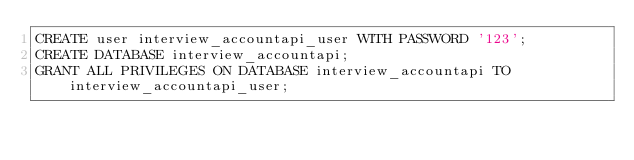Convert code to text. <code><loc_0><loc_0><loc_500><loc_500><_SQL_>CREATE user interview_accountapi_user WITH PASSWORD '123';
CREATE DATABASE interview_accountapi;
GRANT ALL PRIVILEGES ON DATABASE interview_accountapi TO interview_accountapi_user;
</code> 